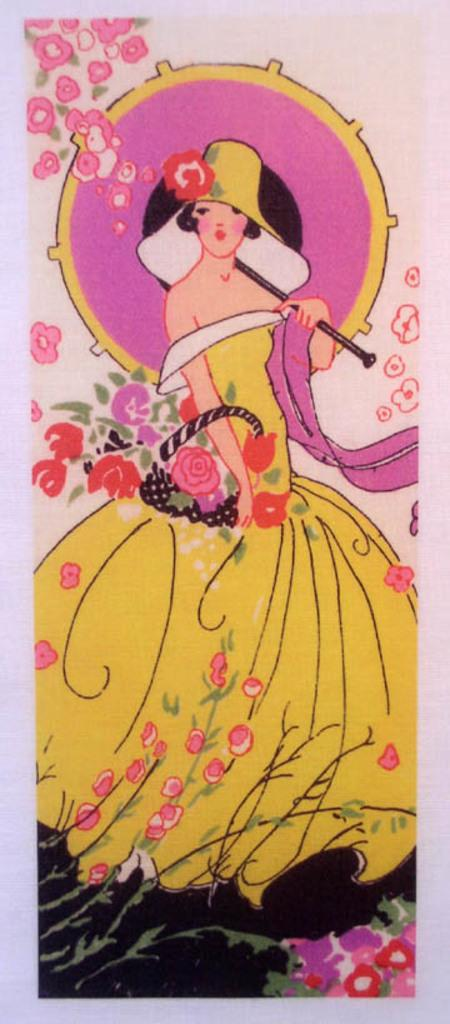What is the main subject of the image? There is a painting in the image. Can you describe the woman in the image? There is a woman standing in the image, and she is holding an object. What type of objects can be seen in the image besides the painting? There are flowers in the image. What color is the background of the image? The background of the image is pink in color. How does the woman rub the bomb in the image? There is no bomb present in the image, and the woman is not rubbing anything. What type of drink is the woman holding in the image? The woman is not holding a drink in the image; she is holding an object, but it is not specified as a drink. 